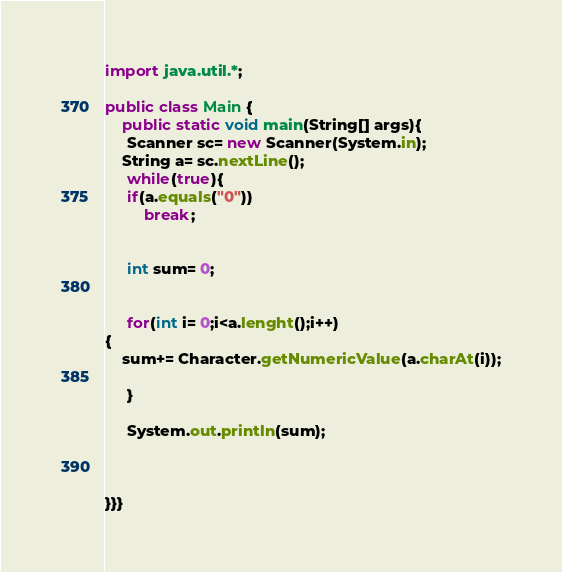Convert code to text. <code><loc_0><loc_0><loc_500><loc_500><_Java_>import java.util.*;

public class Main {
    public static void main(String[] args){
     Scanner sc= new Scanner(System.in);
    String a= sc.nextLine();
     while(true){
     if(a.equals("0")) 
         break;
     
     
     int sum= 0;
     
     
     for(int i= 0;i<a.lenght();i++)
{ 
    sum+= Character.getNumericValue(a.charAt(i));
              
     } 
     
     System.out.println(sum); 
    

   
}}}


</code> 